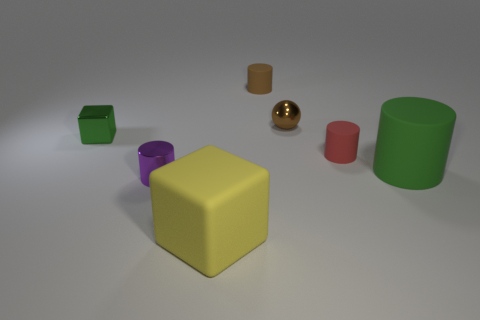There is a green thing that is behind the small red matte cylinder; what shape is it? cube 